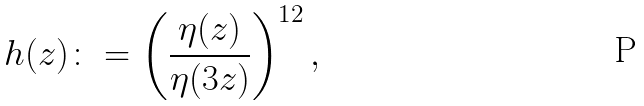<formula> <loc_0><loc_0><loc_500><loc_500>h ( z ) \colon = \left ( \frac { \eta ( z ) } { \eta ( 3 z ) } \right ) ^ { 1 2 } ,</formula> 